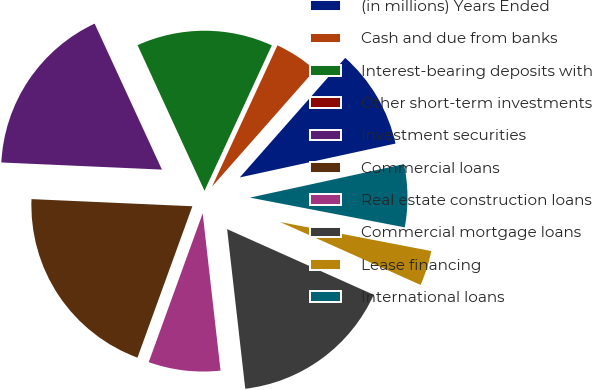Convert chart. <chart><loc_0><loc_0><loc_500><loc_500><pie_chart><fcel>(in millions) Years Ended<fcel>Cash and due from banks<fcel>Interest-bearing deposits with<fcel>Other short-term investments<fcel>Investment securities<fcel>Commercial loans<fcel>Real estate construction loans<fcel>Commercial mortgage loans<fcel>Lease financing<fcel>International loans<nl><fcel>10.09%<fcel>4.6%<fcel>13.76%<fcel>0.02%<fcel>17.42%<fcel>20.17%<fcel>7.34%<fcel>16.5%<fcel>3.68%<fcel>6.43%<nl></chart> 